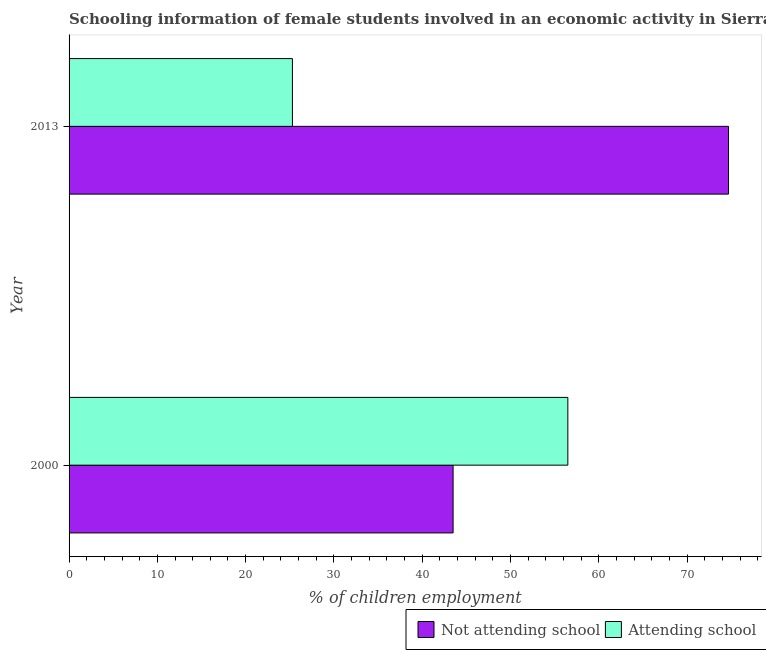How many groups of bars are there?
Your answer should be very brief. 2. Are the number of bars per tick equal to the number of legend labels?
Offer a terse response. Yes. Are the number of bars on each tick of the Y-axis equal?
Keep it short and to the point. Yes. How many bars are there on the 1st tick from the top?
Give a very brief answer. 2. How many bars are there on the 2nd tick from the bottom?
Provide a succinct answer. 2. What is the percentage of employed females who are not attending school in 2000?
Make the answer very short. 43.5. Across all years, what is the maximum percentage of employed females who are attending school?
Your answer should be very brief. 56.5. Across all years, what is the minimum percentage of employed females who are not attending school?
Your answer should be compact. 43.5. In which year was the percentage of employed females who are not attending school maximum?
Provide a short and direct response. 2013. In which year was the percentage of employed females who are not attending school minimum?
Provide a short and direct response. 2000. What is the total percentage of employed females who are not attending school in the graph?
Your answer should be compact. 118.2. What is the difference between the percentage of employed females who are not attending school in 2000 and that in 2013?
Offer a very short reply. -31.2. What is the difference between the percentage of employed females who are attending school in 2000 and the percentage of employed females who are not attending school in 2013?
Provide a short and direct response. -18.2. What is the average percentage of employed females who are not attending school per year?
Your response must be concise. 59.1. In the year 2000, what is the difference between the percentage of employed females who are attending school and percentage of employed females who are not attending school?
Your response must be concise. 13. In how many years, is the percentage of employed females who are attending school greater than 8 %?
Your response must be concise. 2. What is the ratio of the percentage of employed females who are not attending school in 2000 to that in 2013?
Keep it short and to the point. 0.58. Is the difference between the percentage of employed females who are attending school in 2000 and 2013 greater than the difference between the percentage of employed females who are not attending school in 2000 and 2013?
Offer a terse response. Yes. In how many years, is the percentage of employed females who are not attending school greater than the average percentage of employed females who are not attending school taken over all years?
Keep it short and to the point. 1. What does the 1st bar from the top in 2013 represents?
Make the answer very short. Attending school. What does the 2nd bar from the bottom in 2000 represents?
Your answer should be very brief. Attending school. How many bars are there?
Your answer should be very brief. 4. What is the difference between two consecutive major ticks on the X-axis?
Give a very brief answer. 10. Are the values on the major ticks of X-axis written in scientific E-notation?
Your answer should be compact. No. Does the graph contain any zero values?
Provide a short and direct response. No. Where does the legend appear in the graph?
Make the answer very short. Bottom right. How many legend labels are there?
Your answer should be compact. 2. What is the title of the graph?
Your answer should be compact. Schooling information of female students involved in an economic activity in Sierra Leone. Does "% of GNI" appear as one of the legend labels in the graph?
Your answer should be compact. No. What is the label or title of the X-axis?
Provide a short and direct response. % of children employment. What is the label or title of the Y-axis?
Make the answer very short. Year. What is the % of children employment of Not attending school in 2000?
Offer a terse response. 43.5. What is the % of children employment of Attending school in 2000?
Keep it short and to the point. 56.5. What is the % of children employment in Not attending school in 2013?
Your answer should be very brief. 74.7. What is the % of children employment of Attending school in 2013?
Provide a short and direct response. 25.3. Across all years, what is the maximum % of children employment in Not attending school?
Offer a very short reply. 74.7. Across all years, what is the maximum % of children employment of Attending school?
Your answer should be compact. 56.5. Across all years, what is the minimum % of children employment in Not attending school?
Provide a short and direct response. 43.5. Across all years, what is the minimum % of children employment of Attending school?
Keep it short and to the point. 25.3. What is the total % of children employment of Not attending school in the graph?
Your response must be concise. 118.2. What is the total % of children employment of Attending school in the graph?
Provide a succinct answer. 81.8. What is the difference between the % of children employment of Not attending school in 2000 and that in 2013?
Your response must be concise. -31.2. What is the difference between the % of children employment of Attending school in 2000 and that in 2013?
Give a very brief answer. 31.2. What is the average % of children employment of Not attending school per year?
Your answer should be very brief. 59.1. What is the average % of children employment of Attending school per year?
Offer a very short reply. 40.9. In the year 2013, what is the difference between the % of children employment of Not attending school and % of children employment of Attending school?
Your answer should be very brief. 49.4. What is the ratio of the % of children employment in Not attending school in 2000 to that in 2013?
Your answer should be compact. 0.58. What is the ratio of the % of children employment of Attending school in 2000 to that in 2013?
Keep it short and to the point. 2.23. What is the difference between the highest and the second highest % of children employment of Not attending school?
Offer a very short reply. 31.2. What is the difference between the highest and the second highest % of children employment in Attending school?
Ensure brevity in your answer.  31.2. What is the difference between the highest and the lowest % of children employment of Not attending school?
Make the answer very short. 31.2. What is the difference between the highest and the lowest % of children employment of Attending school?
Your answer should be compact. 31.2. 